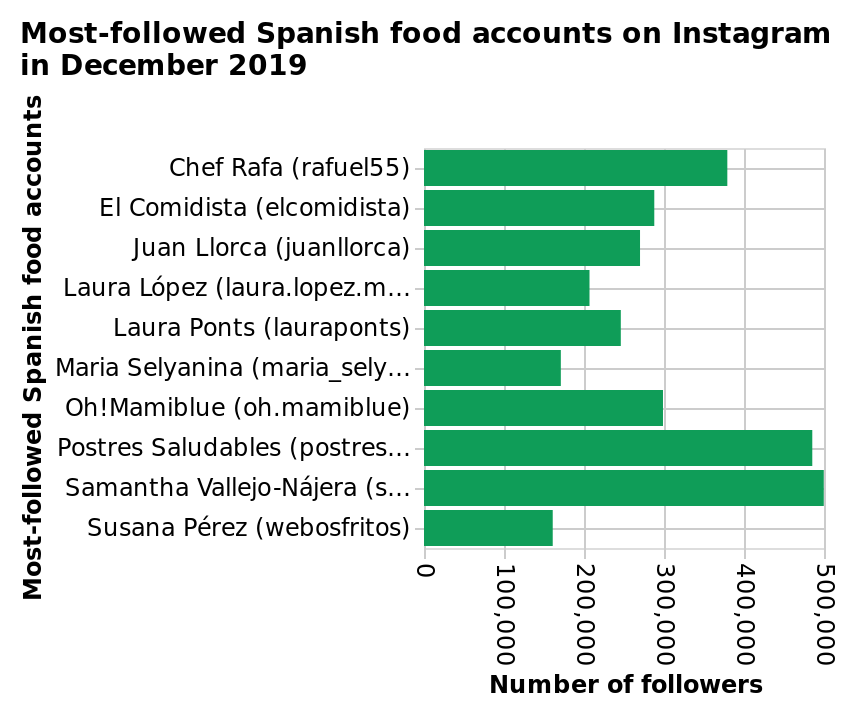<image>
Which Spanish food account has the highest number of followers? Susana Pérez (webosfritos) has the highest number of followers among the Spanish food accounts. please enumerates aspects of the construction of the chart This is a bar chart called Most-followed Spanish food accounts on Instagram in December 2019. There is a linear scale from 0 to 500,000 on the x-axis, labeled Number of followers. The y-axis measures Most-followed Spanish food accounts on a categorical scale from Chef Rafa (rafuel55) to Susana Pérez (webosfritos). Which person mentioned in the figure has the highest number of followers? Samantha Vallejo-Najera has the highest number of followers. Who has the lowest number of followers among the mentioned individuals? Susana Perez has the lowest number of followers. 